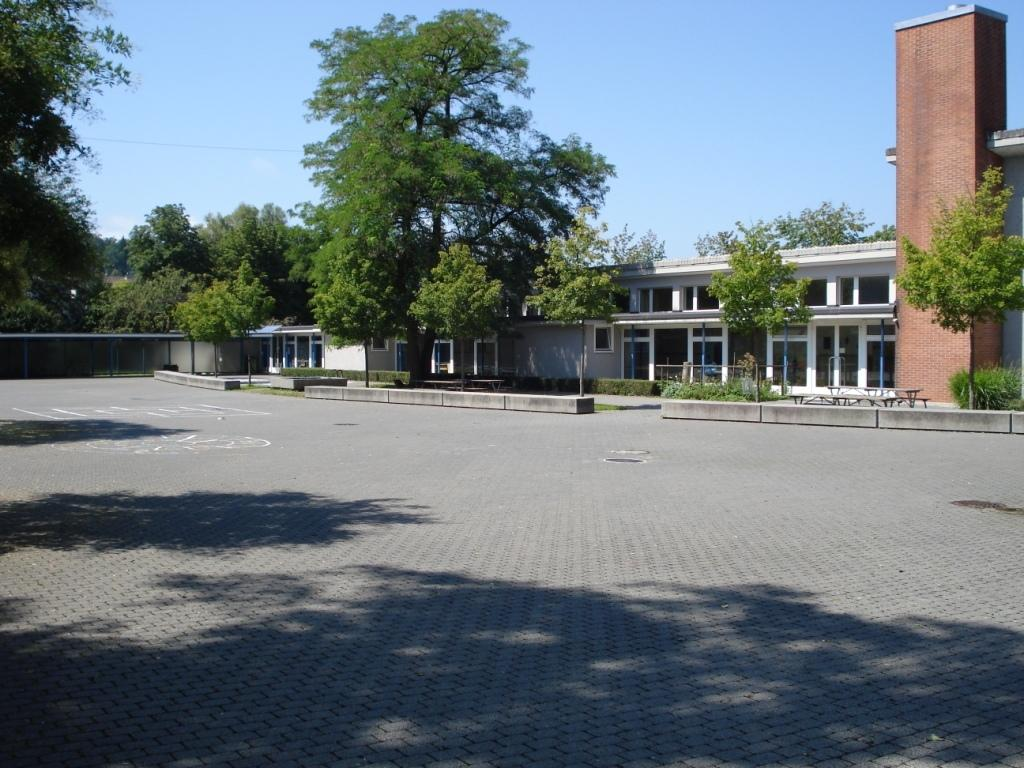What type of vegetation is on the left side of the image? There are green trees on the left side of the image. What structure can be seen on the right side of the image? There appears to be a house on the right side of the image. What is visible at the top of the image? The sky is visible at the top of the image. What is the weather like in the image? The sky is sunny, indicating a clear and bright day. Can you tell me how many beams are supporting the house in the image? There is no information about beams or the house's structure in the image, so it is not possible to answer that question. What level of the house is shown in the image? The image only shows the exterior of the house, so it is not possible to determine the level being depicted. 